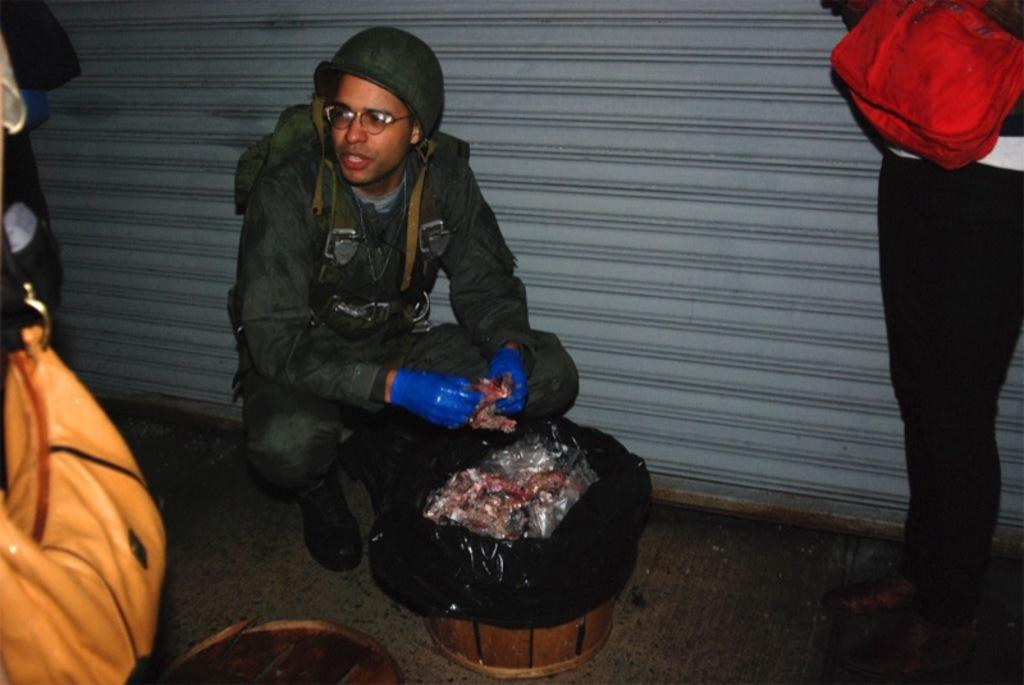What is the person in the image holding? There is a person holding an object in the image, but the specific object is not mentioned in the facts. How many other persons are present in the image? There are other persons standing beside the person holding the object. Can you describe the interaction between the person holding the object and the other persons? The facts do not provide enough information to describe the interaction between the person holding the object and the other persons. What type of insurance does the person holding the object have in the image? There is no information about insurance in the image, as the facts only mention a person holding an object and other persons standing beside them. 